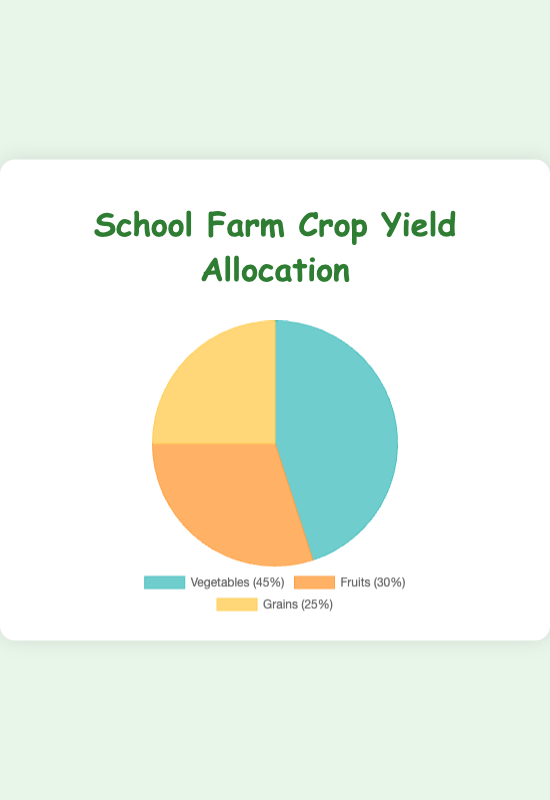What percentage of the school's crops are Vegetables? The pie chart shows that Vegetables make up 45% of the school's crops.
Answer: 45% What is the combined percentage of Fruits and Grains? Fruits make up 30% and Grains make up 25%. Adding these together gives us: 30% + 25% = 55%.
Answer: 55% Which crop has the largest allocation in the school's farm? The pie chart indicates that Vegetables have the highest percentage with 45%.
Answer: Vegetables How much greater is the percentage of Vegetables compared to Grains? Vegetables make up 45% and Grains make up 25%. The difference is 45% - 25% = 20%.
Answer: 20% What are the main crops included in the Vegetables section of the pie chart? The tooltip information for Vegetables lists Carrots, Tomatoes, and Spinach.
Answer: Carrots, Tomatoes, Spinach Is the percentage of Fruits less than half the percentage of Vegetables? Vegetables make up 45%, half of which is 22.5%. Since Fruits are 30%, 30% is greater than 22.5%.
Answer: No What examples of Fruits are cultivated on the school farm? The tooltip for Fruits lists Apples, Blueberries, and Strawberries.
Answer: Apples, Blueberries, Strawberries Are Grains more than one-third of the total crop yield? One-third of the total crop yield is approximately 33.33%. Grains are 25%, which is less than one-third.
Answer: No Which crop category occupies the area with the orange-ish color on the pie chart? The orange-ish color on the chart corresponds to the Fruits section, which is 30%.
Answer: Fruits What is the total percentage allocation of all three crop types combined? The total percentage allocation is the sum of all three categories: Vegetables (45%) + Fruits (30%) + Grains (25%) = 100%.
Answer: 100% 